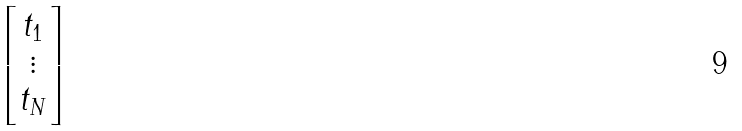Convert formula to latex. <formula><loc_0><loc_0><loc_500><loc_500>\begin{bmatrix} t _ { 1 } \\ \vdots \\ t _ { N } \\ \end{bmatrix}</formula> 